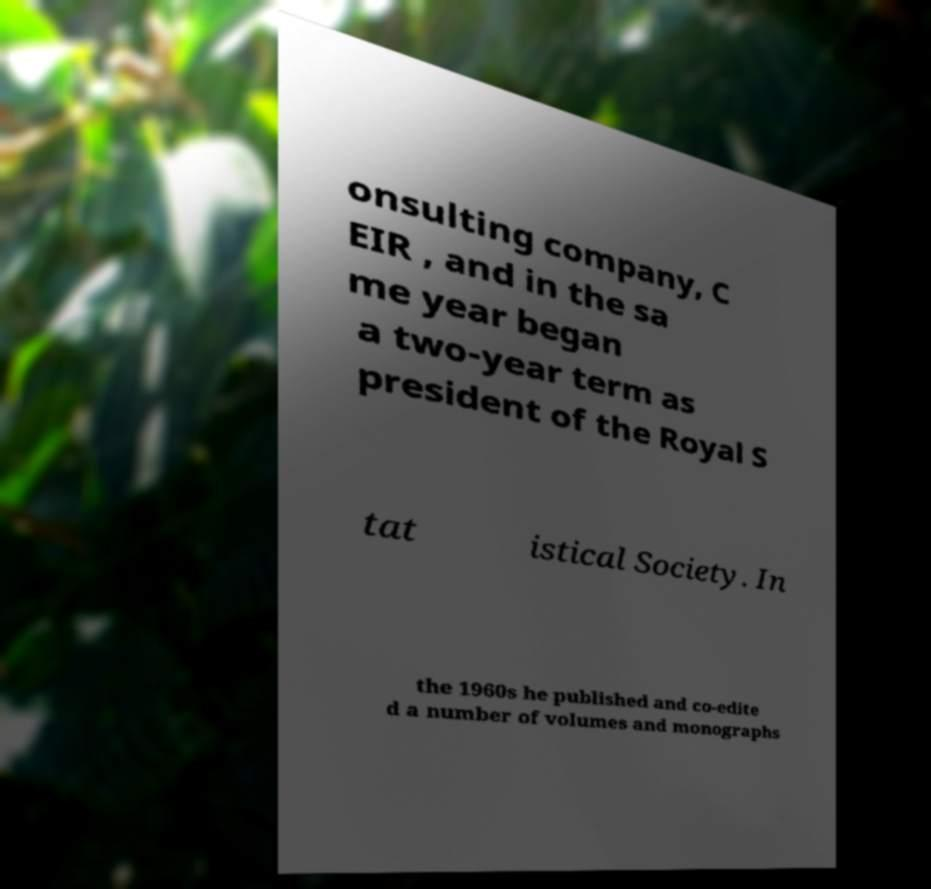There's text embedded in this image that I need extracted. Can you transcribe it verbatim? onsulting company, C EIR , and in the sa me year began a two-year term as president of the Royal S tat istical Society. In the 1960s he published and co-edite d a number of volumes and monographs 